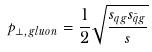<formula> <loc_0><loc_0><loc_500><loc_500>p _ { \perp , g l u o n } = \frac { 1 } { 2 } \sqrt { \frac { s _ { q g } s _ { \bar { q } g } } { s } }</formula> 